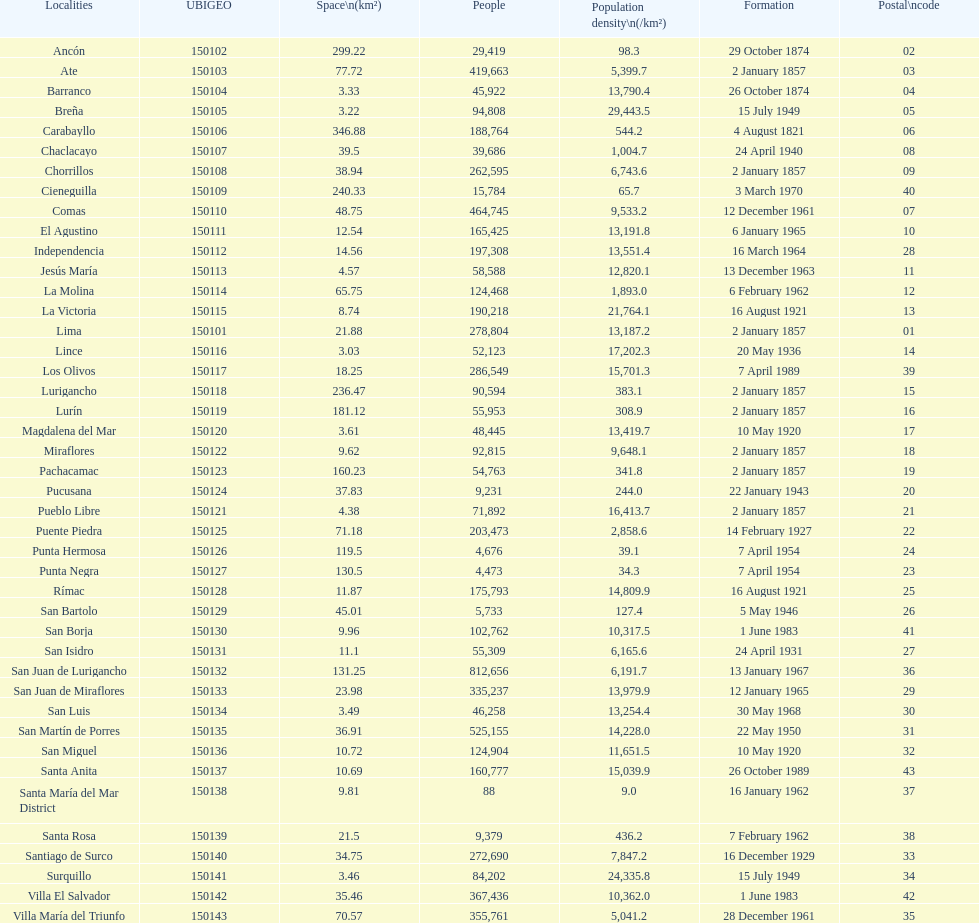How many districts have a population density of at lest 1000.0? 31. 